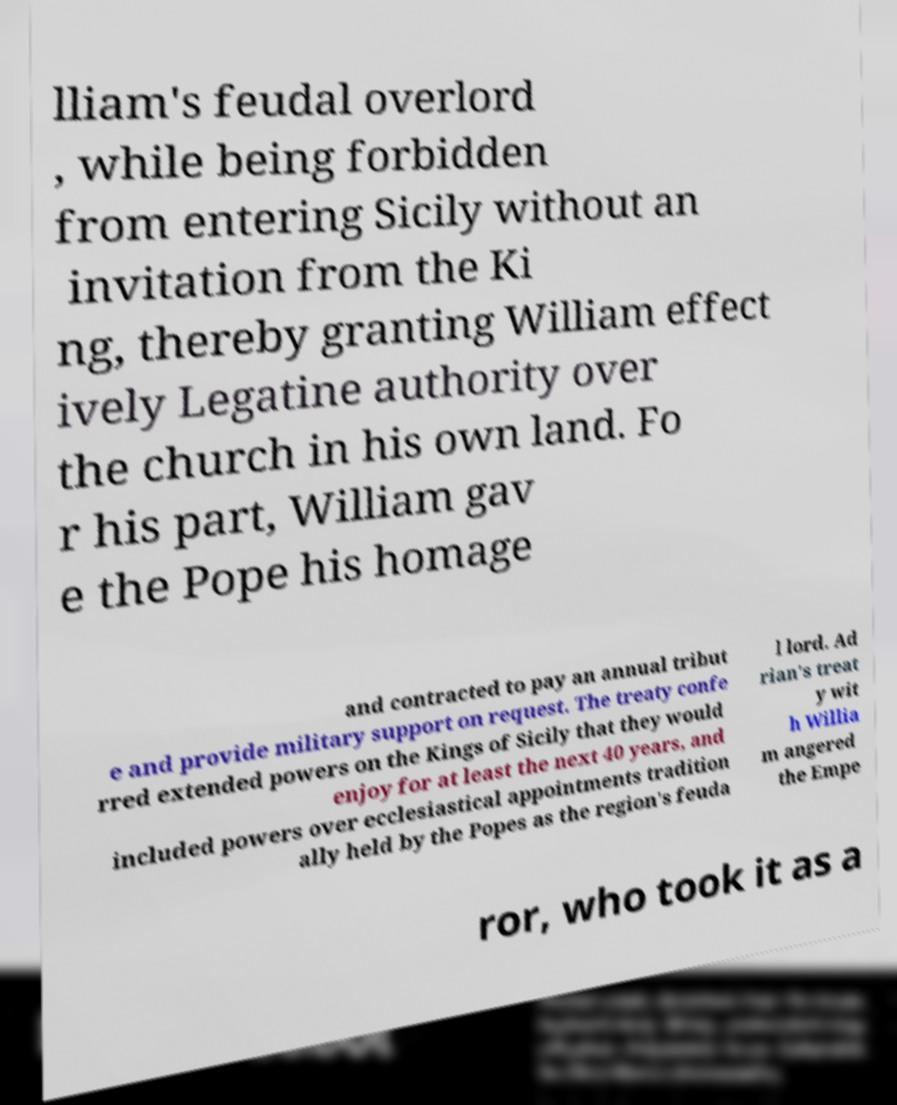Please identify and transcribe the text found in this image. lliam's feudal overlord , while being forbidden from entering Sicily without an invitation from the Ki ng, thereby granting William effect ively Legatine authority over the church in his own land. Fo r his part, William gav e the Pope his homage and contracted to pay an annual tribut e and provide military support on request. The treaty confe rred extended powers on the Kings of Sicily that they would enjoy for at least the next 40 years, and included powers over ecclesiastical appointments tradition ally held by the Popes as the region's feuda l lord. Ad rian's treat y wit h Willia m angered the Empe ror, who took it as a 